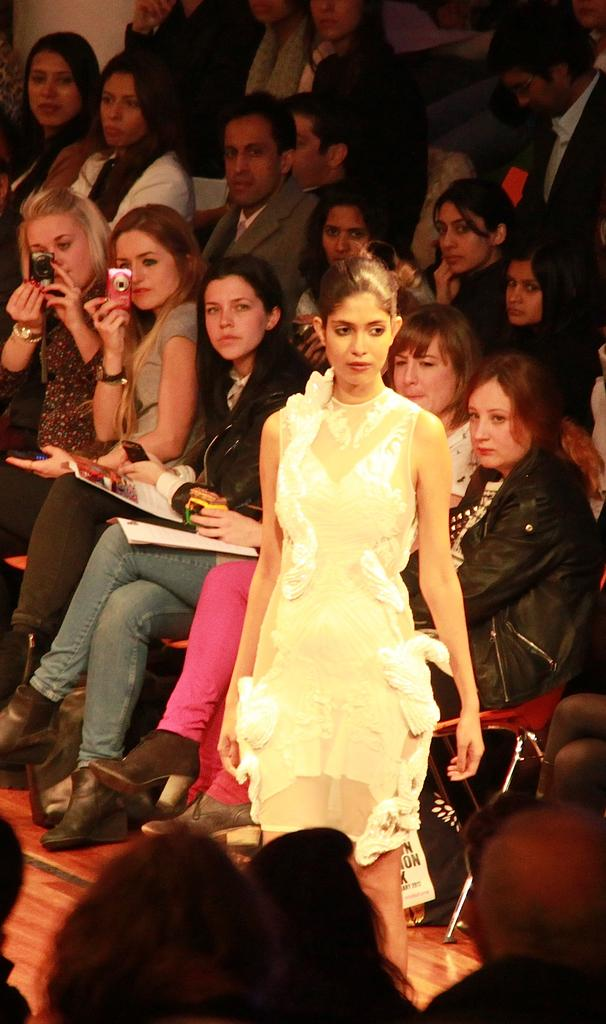What are the people in the image doing? The people in the image are sitting on chairs. Can you describe the woman in the image? There is a woman standing on the floor in the image. What are the two women holding in the image? The two women are holding cameras in the image. What is the purpose of the north pole in the image? There is no mention of the north pole in the image, so it cannot be determined what its purpose might be. 